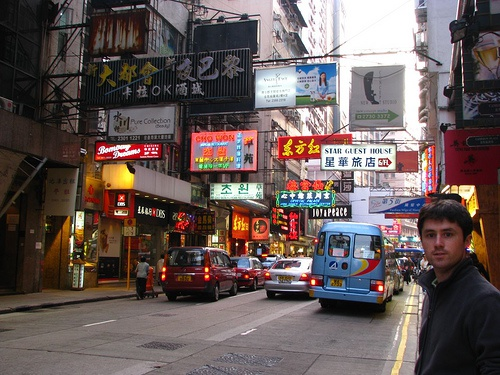Describe the objects in this image and their specific colors. I can see people in black, maroon, and brown tones, bus in black, blue, and gray tones, car in black, maroon, gray, and brown tones, car in black, white, gray, and darkgray tones, and car in black, maroon, gray, and brown tones in this image. 